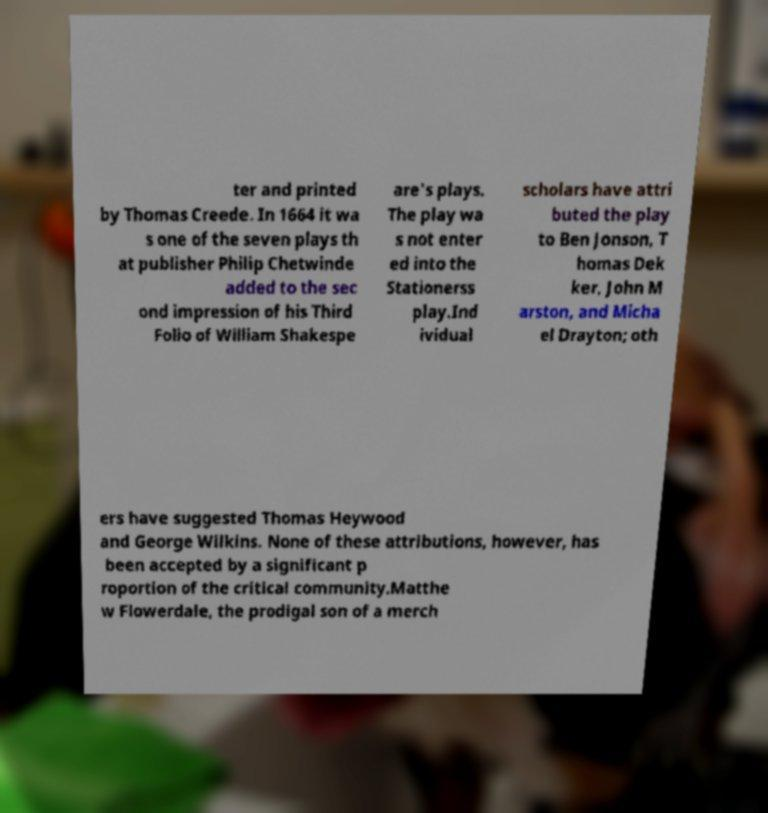Can you read and provide the text displayed in the image?This photo seems to have some interesting text. Can you extract and type it out for me? ter and printed by Thomas Creede. In 1664 it wa s one of the seven plays th at publisher Philip Chetwinde added to the sec ond impression of his Third Folio of William Shakespe are's plays. The play wa s not enter ed into the Stationerss play.Ind ividual scholars have attri buted the play to Ben Jonson, T homas Dek ker, John M arston, and Micha el Drayton; oth ers have suggested Thomas Heywood and George Wilkins. None of these attributions, however, has been accepted by a significant p roportion of the critical community.Matthe w Flowerdale, the prodigal son of a merch 